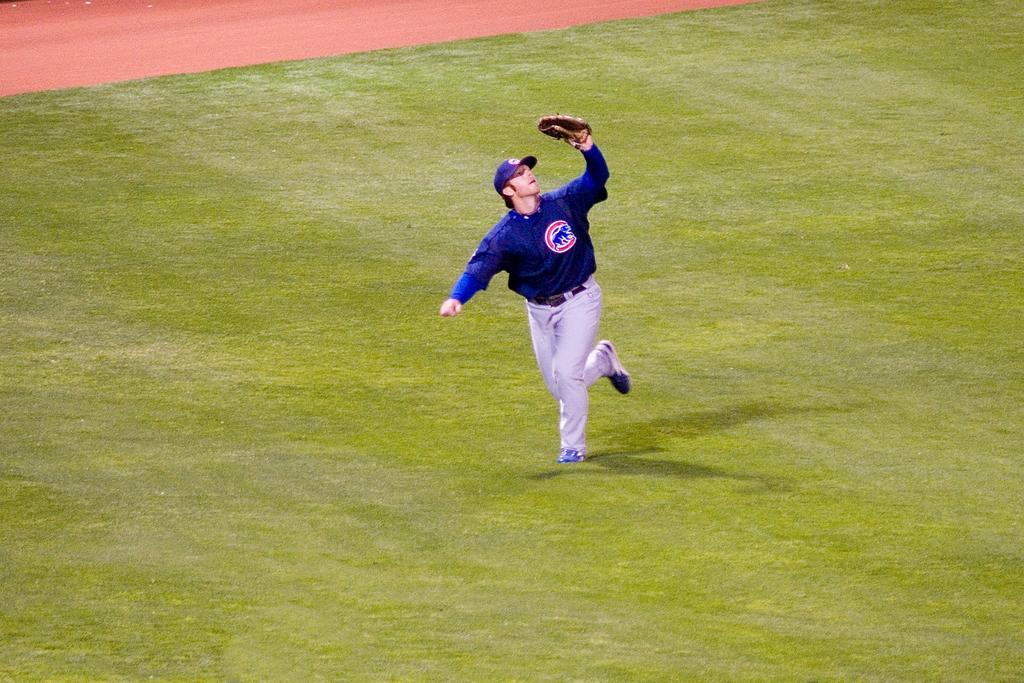How would you summarize this image in a sentence or two? In this image one person is running on the surface of the grass by holding some object. 